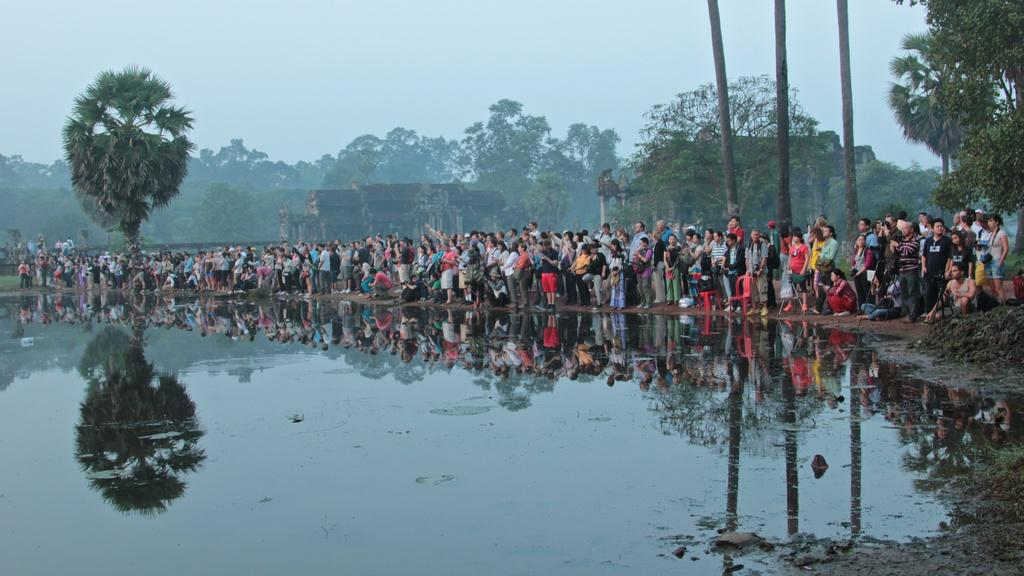What is the main subject in the center of the image? There is water in the center of the image. What else can be seen in the image besides the water? There are buildings, trees, and a group of people in the image. Where are the buildings located in relation to the water? The buildings are located near the water in the image. What is visible in the background of the image? The sky is visible in the background of the image, and there are clouds present. What type of cord is being used to maintain peace among the group of people in the image? There is no cord present in the image, and the group of people are not depicted as needing assistance in maintaining peace. 